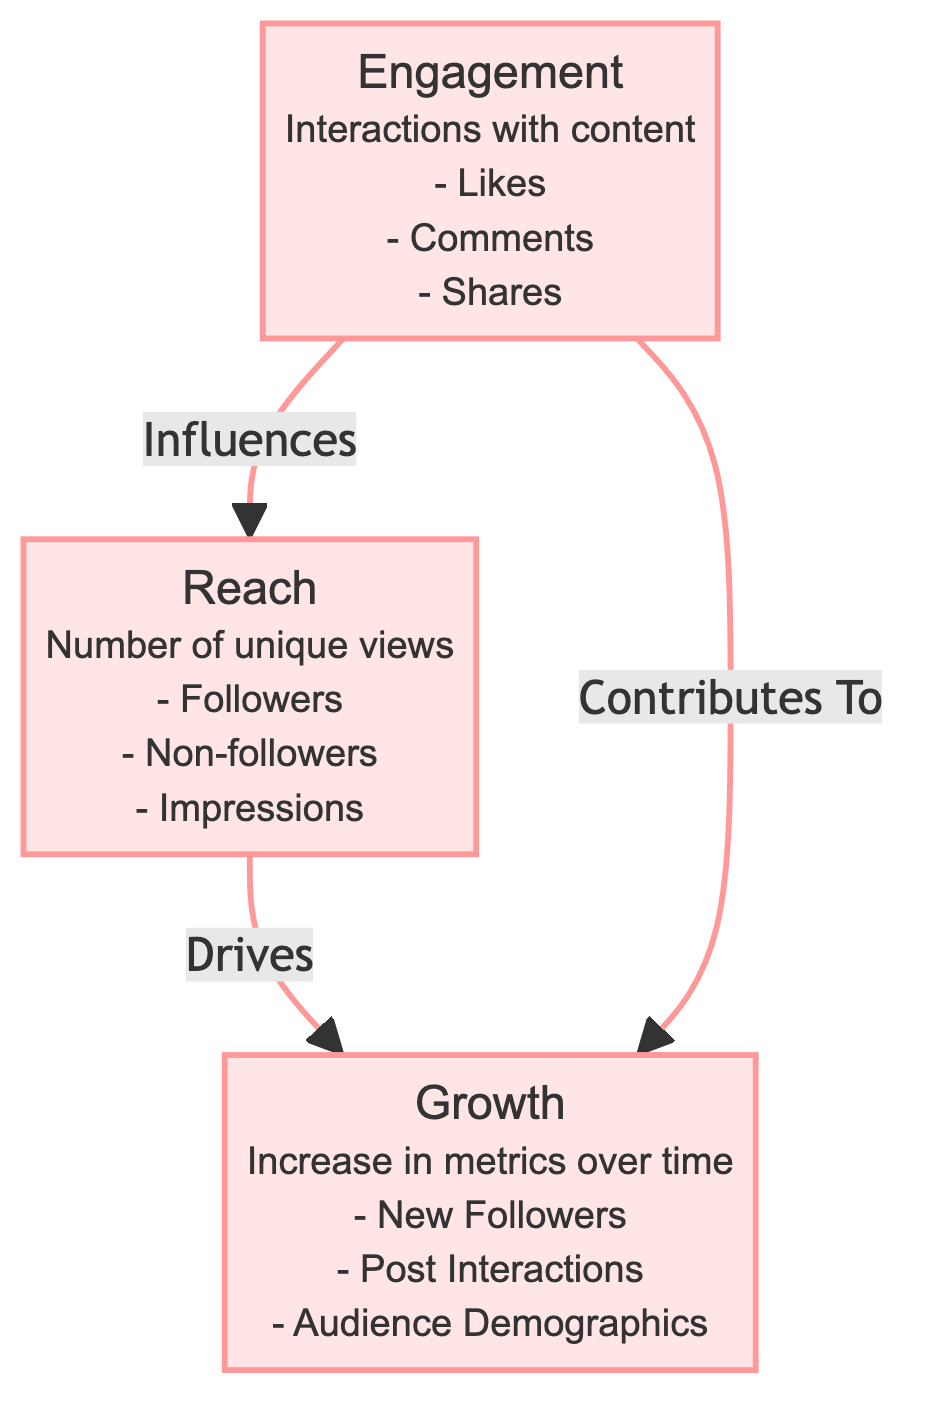What are the three main metrics depicted in the diagram? The diagram displays three main metrics: Engagement, Reach, and Growth. Each of these metrics is represented as a separate node in the diagram, clearly labeled.
Answer: Engagement, Reach, Growth How many unique views are included in the definition of Reach? The definition of Reach includes three aspects: Followers, Non-followers, and Impressions. These are listed under the Reach node, indicating the various components of this metric.
Answer: Three What influences Reach according to the diagram? The diagram states that Engagement influences Reach, indicated by the directed arrow from the Engagement node to the Reach node. This shows a direct relationship where one affects the other.
Answer: Engagement Which metric drives Growth? The diagram indicates that Reach drives Growth, as shown by the directed arrow pointing from the Reach node to the Growth node. This indicates that an increase in Reach leads to Growth.
Answer: Reach How does Engagement contribute to Growth? The diagram illustrates that Engagement contributes to Growth, which is indicated by another directed arrow pointing from the Engagement node to the Growth node. This implies that active interaction with content promotes growth metrics.
Answer: Contributes To What type of connections exist between the Engagement, Reach, and Growth nodes? All connections between the nodes are directed relationships, indicating the influence and contribution dynamics among the three metrics, visually represented with arrows showing the direction.
Answer: Directed relationships Which aspect listed under Engagement specifically relates to actions taken by users? The aspect of Engagement that relates to user actions includes Likes, Comments, and Shares, which are specifically about user interaction with content.
Answer: Interactions What does the term "New Followers" refer to in the context of Growth? "New Followers" refers to an increase in the number of unique individuals following the account over time, which signifies a growth in audience size. It is listed under the Growth node.
Answer: Increase in followers How many edges (connections) are present in the diagram? There are three directed connections (edges) represented in the diagram, each showing the flow of influence between the metrics: Engagement to Reach, Reach to Growth, and Engagement to Growth.
Answer: Three 